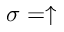Convert formula to latex. <formula><loc_0><loc_0><loc_500><loc_500>\sigma = \uparrow</formula> 